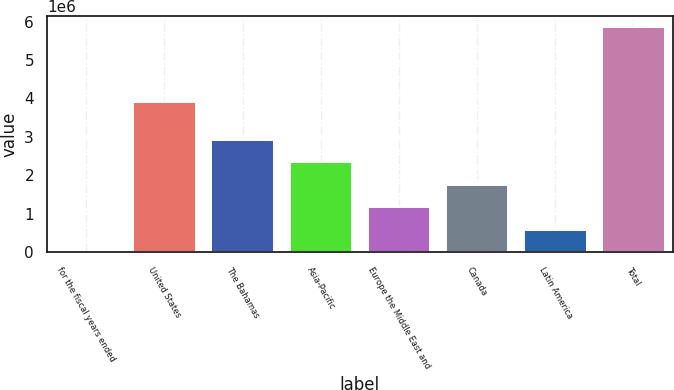Convert chart to OTSL. <chart><loc_0><loc_0><loc_500><loc_500><bar_chart><fcel>for the fiscal years ended<fcel>United States<fcel>The Bahamas<fcel>Asia-Pacific<fcel>Europe the Middle East and<fcel>Canada<fcel>Latin America<fcel>Total<nl><fcel>2010<fcel>3.91995e+06<fcel>2.9275e+06<fcel>2.34241e+06<fcel>1.17221e+06<fcel>1.75731e+06<fcel>587109<fcel>5.853e+06<nl></chart> 